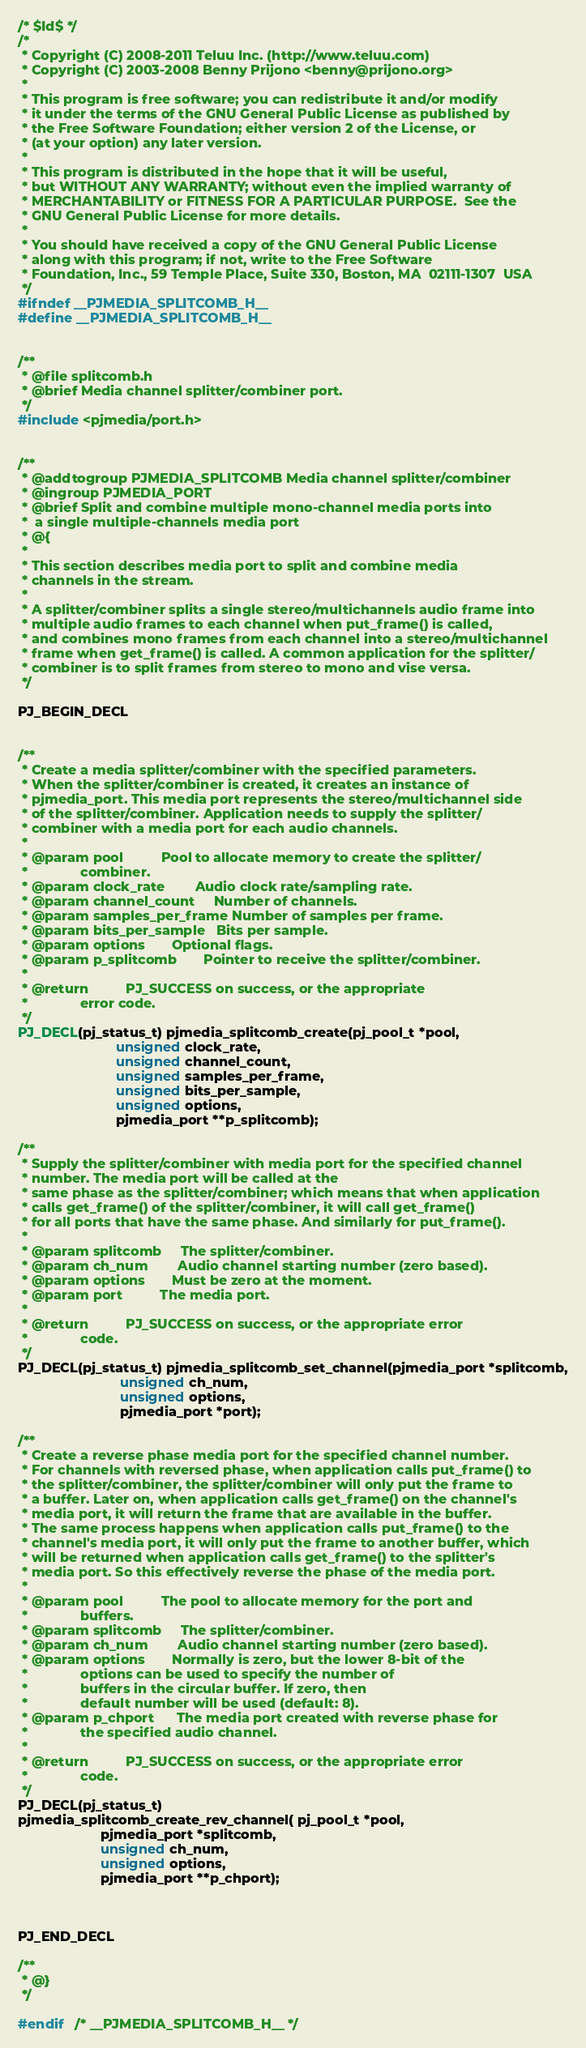<code> <loc_0><loc_0><loc_500><loc_500><_C_>/* $Id$ */
/* 
 * Copyright (C) 2008-2011 Teluu Inc. (http://www.teluu.com)
 * Copyright (C) 2003-2008 Benny Prijono <benny@prijono.org>
 *
 * This program is free software; you can redistribute it and/or modify
 * it under the terms of the GNU General Public License as published by
 * the Free Software Foundation; either version 2 of the License, or
 * (at your option) any later version.
 *
 * This program is distributed in the hope that it will be useful,
 * but WITHOUT ANY WARRANTY; without even the implied warranty of
 * MERCHANTABILITY or FITNESS FOR A PARTICULAR PURPOSE.  See the
 * GNU General Public License for more details.
 *
 * You should have received a copy of the GNU General Public License
 * along with this program; if not, write to the Free Software
 * Foundation, Inc., 59 Temple Place, Suite 330, Boston, MA  02111-1307  USA 
 */
#ifndef __PJMEDIA_SPLITCOMB_H__
#define __PJMEDIA_SPLITCOMB_H__


/**
 * @file splitcomb.h
 * @brief Media channel splitter/combiner port.
 */
#include <pjmedia/port.h>


/**
 * @addtogroup PJMEDIA_SPLITCOMB Media channel splitter/combiner
 * @ingroup PJMEDIA_PORT
 * @brief Split and combine multiple mono-channel media ports into
 *  a single multiple-channels media port
 * @{
 *
 * This section describes media port to split and combine media
 * channels in the stream.
 *
 * A splitter/combiner splits a single stereo/multichannels audio frame into
 * multiple audio frames to each channel when put_frame() is called, 
 * and combines mono frames from each channel into a stereo/multichannel 
 * frame when get_frame() is called. A common application for the splitter/
 * combiner is to split frames from stereo to mono and vise versa.
 */

PJ_BEGIN_DECL


/**
 * Create a media splitter/combiner with the specified parameters.
 * When the splitter/combiner is created, it creates an instance of
 * pjmedia_port. This media port represents the stereo/multichannel side
 * of the splitter/combiner. Application needs to supply the splitter/
 * combiner with a media port for each audio channels.
 *
 * @param pool		    Pool to allocate memory to create the splitter/
 *			    combiner.
 * @param clock_rate	    Audio clock rate/sampling rate.
 * @param channel_count	    Number of channels.
 * @param samples_per_frame Number of samples per frame.
 * @param bits_per_sample   Bits per sample.
 * @param options	    Optional flags.
 * @param p_splitcomb	    Pointer to receive the splitter/combiner.
 *
 * @return		    PJ_SUCCESS on success, or the appropriate
 *			    error code.
 */
PJ_DECL(pj_status_t) pjmedia_splitcomb_create(pj_pool_t *pool,
					      unsigned clock_rate,
					      unsigned channel_count,
					      unsigned samples_per_frame,
					      unsigned bits_per_sample,
					      unsigned options,
					      pjmedia_port **p_splitcomb);

/**
 * Supply the splitter/combiner with media port for the specified channel 
 * number. The media port will be called at the
 * same phase as the splitter/combiner; which means that when application
 * calls get_frame() of the splitter/combiner, it will call get_frame()
 * for all ports that have the same phase. And similarly for put_frame().
 *
 * @param splitcomb	    The splitter/combiner.
 * @param ch_num	    Audio channel starting number (zero based).
 * @param options	    Must be zero at the moment.
 * @param port		    The media port.
 *
 * @return		    PJ_SUCCESS on success, or the appropriate error
 *			    code.
 */
PJ_DECL(pj_status_t) pjmedia_splitcomb_set_channel(pjmedia_port *splitcomb,
						   unsigned ch_num,
						   unsigned options,
						   pjmedia_port *port);

/**
 * Create a reverse phase media port for the specified channel number.
 * For channels with reversed phase, when application calls put_frame() to
 * the splitter/combiner, the splitter/combiner will only put the frame to
 * a buffer. Later on, when application calls get_frame() on the channel's
 * media port, it will return the frame that are available in the buffer.
 * The same process happens when application calls put_frame() to the
 * channel's media port, it will only put the frame to another buffer, which
 * will be returned when application calls get_frame() to the splitter's 
 * media port. So this effectively reverse the phase of the media port.
 *
 * @param pool		    The pool to allocate memory for the port and
 *			    buffers.
 * @param splitcomb	    The splitter/combiner.
 * @param ch_num	    Audio channel starting number (zero based).
 * @param options	    Normally is zero, but the lower 8-bit of the 
 *			    options can be used to specify the number of 
 *			    buffers in the circular buffer. If zero, then
 *			    default number will be used (default: 8).
 * @param p_chport	    The media port created with reverse phase for
 *			    the specified audio channel.
 *
 * @return		    PJ_SUCCESS on success, or the appropriate error
 *			    code.
 */
PJ_DECL(pj_status_t) 
pjmedia_splitcomb_create_rev_channel( pj_pool_t *pool,
				      pjmedia_port *splitcomb,
				      unsigned ch_num,
				      unsigned options,
				      pjmedia_port **p_chport);



PJ_END_DECL

/**
 * @}
 */

#endif	/* __PJMEDIA_SPLITCOMB_H__ */


</code> 